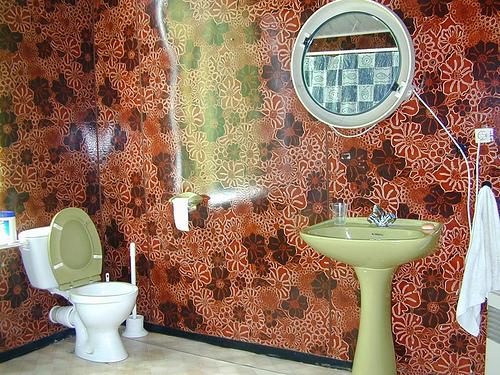What was the gender of the last person to use the toilet?
Give a very brief answer. Male. What style sink is shown?
Write a very short answer. Pedestal. Would Martha Stewart like the decoration in this room?
Answer briefly. No. 